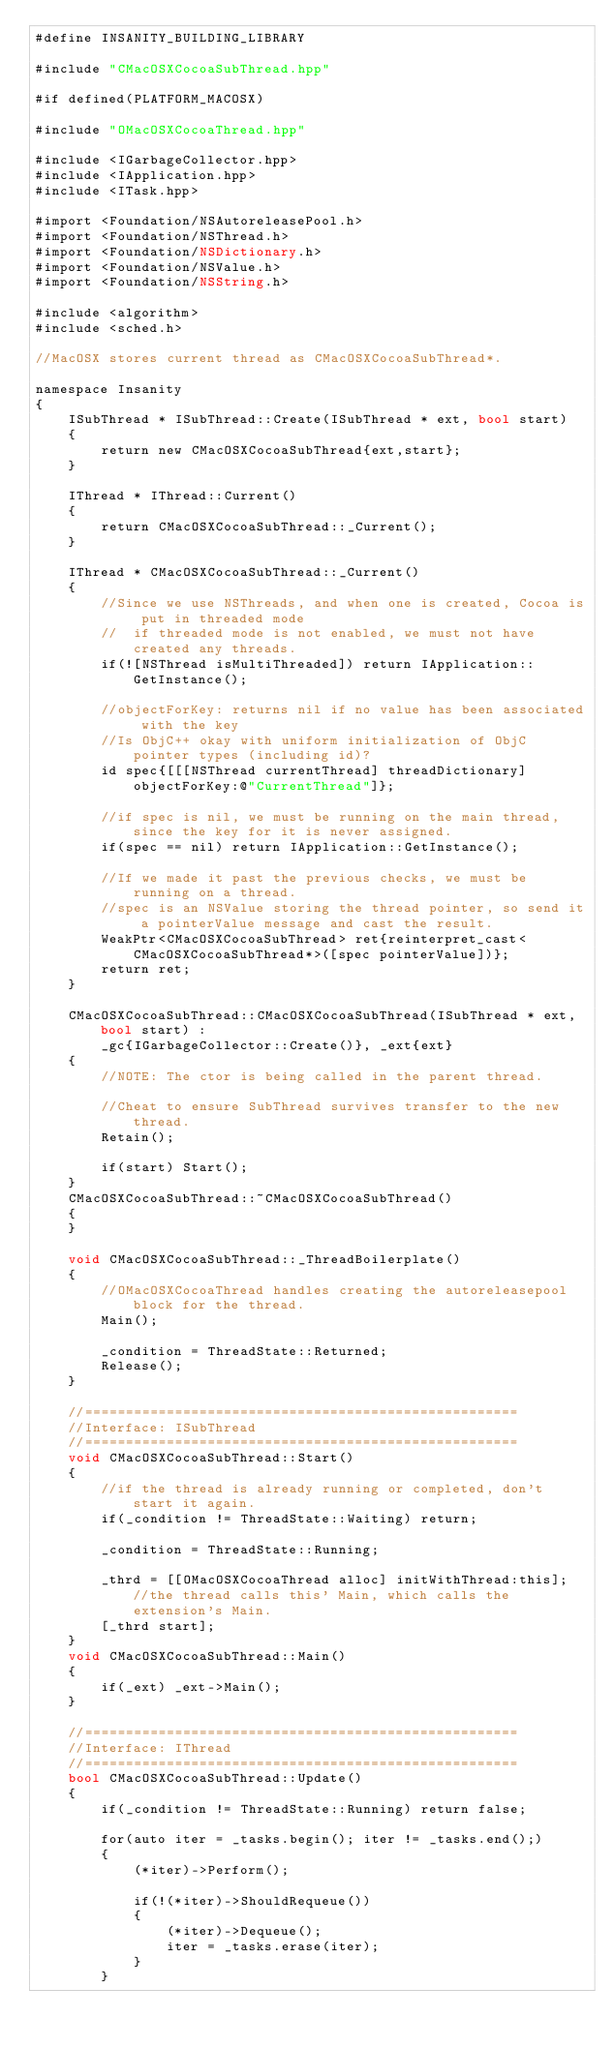<code> <loc_0><loc_0><loc_500><loc_500><_ObjectiveC_>#define INSANITY_BUILDING_LIBRARY

#include "CMacOSXCocoaSubThread.hpp"

#if defined(PLATFORM_MACOSX)

#include "OMacOSXCocoaThread.hpp"

#include <IGarbageCollector.hpp>
#include <IApplication.hpp>
#include <ITask.hpp>

#import <Foundation/NSAutoreleasePool.h>
#import <Foundation/NSThread.h>
#import <Foundation/NSDictionary.h>
#import <Foundation/NSValue.h>
#import <Foundation/NSString.h>

#include <algorithm>
#include <sched.h>

//MacOSX stores current thread as CMacOSXCocoaSubThread*.

namespace Insanity
{
	ISubThread * ISubThread::Create(ISubThread * ext, bool start)
	{
		return new CMacOSXCocoaSubThread{ext,start};
	}
	
	IThread * IThread::Current()
	{
		return CMacOSXCocoaSubThread::_Current();
	}
	
	IThread * CMacOSXCocoaSubThread::_Current()
	{
		//Since we use NSThreads, and when one is created, Cocoa is put in threaded mode
		//	if threaded mode is not enabled, we must not have created any threads.
		if(![NSThread isMultiThreaded]) return IApplication::GetInstance();
		
		//objectForKey: returns nil if no value has been associated with the key
		//Is ObjC++ okay with uniform initialization of ObjC pointer types (including id)?
		id spec{[[[NSThread currentThread] threadDictionary] objectForKey:@"CurrentThread"]};
		
		//if spec is nil, we must be running on the main thread, since the key for it is never assigned.
		if(spec == nil) return IApplication::GetInstance();
		
		//If we made it past the previous checks, we must be running on a thread.
		//spec is an NSValue storing the thread pointer, so send it a pointerValue message and cast the result.
        WeakPtr<CMacOSXCocoaSubThread> ret{reinterpret_cast<CMacOSXCocoaSubThread*>([spec pointerValue])};
        return ret;
	}
	
	CMacOSXCocoaSubThread::CMacOSXCocoaSubThread(ISubThread * ext, bool start) :
		_gc{IGarbageCollector::Create()}, _ext{ext}
	{
		//NOTE: The ctor is being called in the parent thread.
		
		//Cheat to ensure SubThread survives transfer to the new thread.
		Retain();
		
		if(start) Start();
	}
	CMacOSXCocoaSubThread::~CMacOSXCocoaSubThread()
	{
	}
	
	void CMacOSXCocoaSubThread::_ThreadBoilerplate()
	{
		//OMacOSXCocoaThread handles creating the autoreleasepool block for the thread.
		Main();

		_condition = ThreadState::Returned;
		Release();
	}
	
	//=====================================================
	//Interface: ISubThread
	//=====================================================
	void CMacOSXCocoaSubThread::Start()
	{
		//if the thread is already running or completed, don't start it again.
		if(_condition != ThreadState::Waiting) return;

		_condition = ThreadState::Running;
		
		_thrd = [[OMacOSXCocoaThread alloc] initWithThread:this]; //the thread calls this' Main, which calls the extension's Main.
		[_thrd start];
	}
	void CMacOSXCocoaSubThread::Main()
	{
        if(_ext) _ext->Main();
	}
	
	//=====================================================
	//Interface: IThread
	//=====================================================
	bool CMacOSXCocoaSubThread::Update()
	{
		if(_condition != ThreadState::Running) return false;

		for(auto iter = _tasks.begin(); iter != _tasks.end();)
		{
			(*iter)->Perform();

			if(!(*iter)->ShouldRequeue())
			{
				(*iter)->Dequeue();
				iter = _tasks.erase(iter);
			}
		}
</code> 